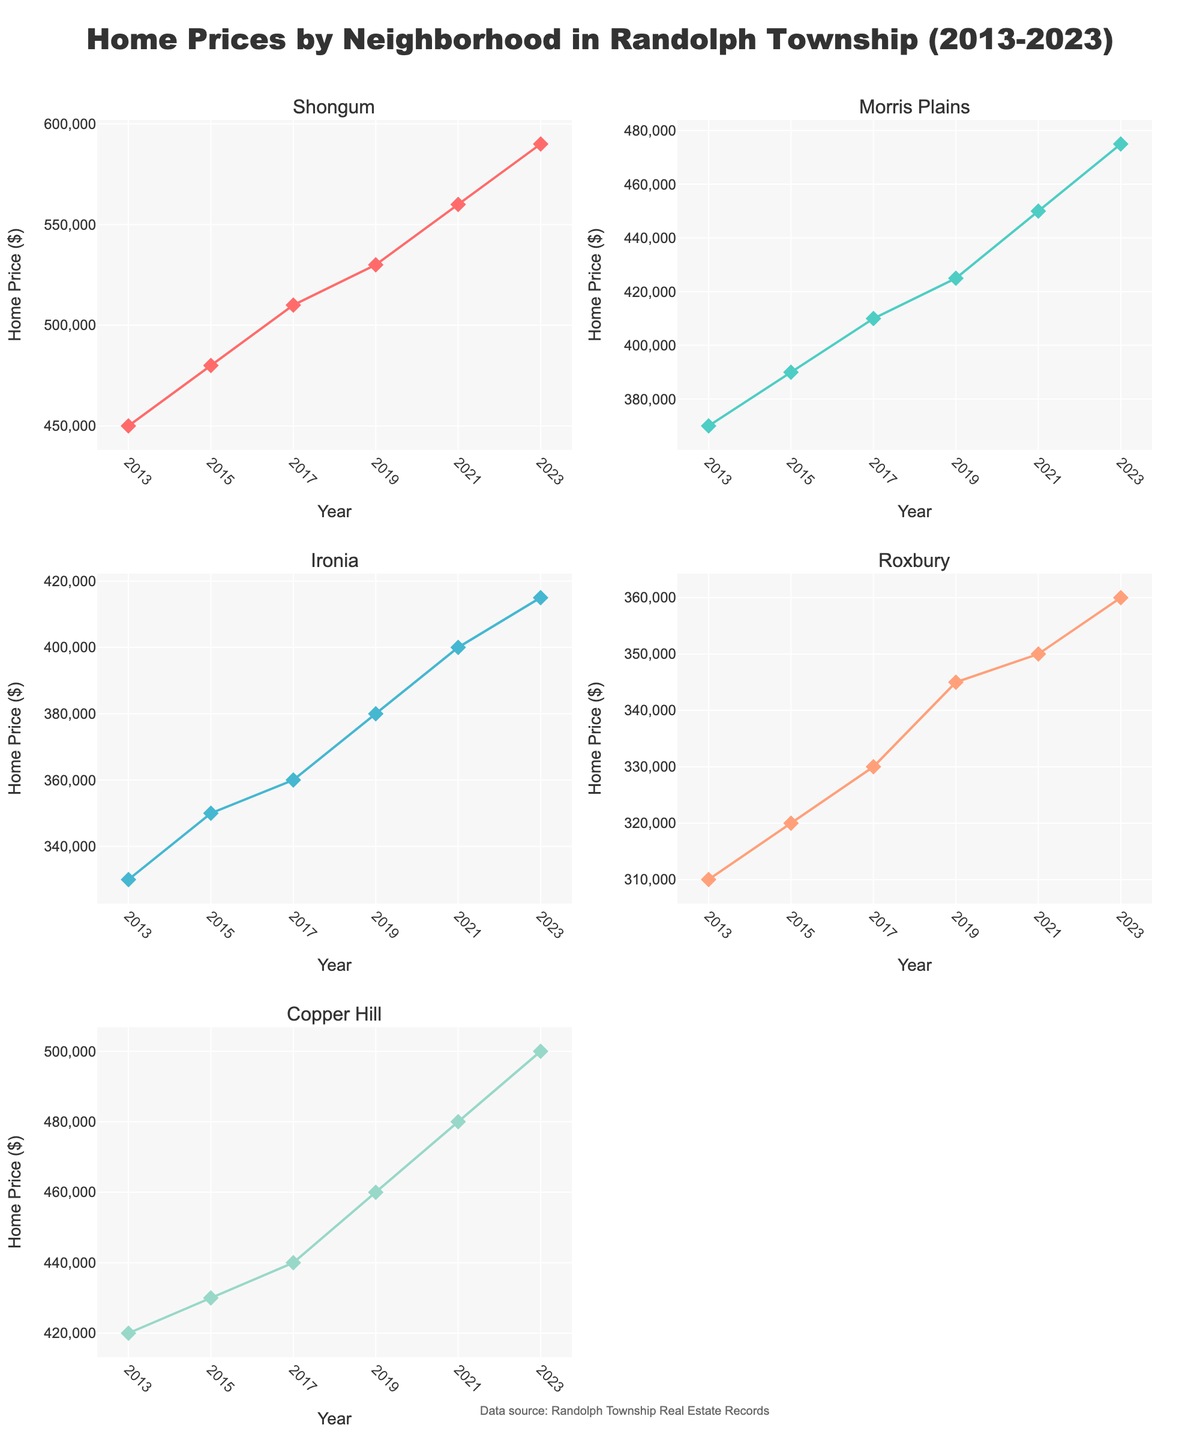what is the title of the figure? The title appears at the top of the figure and provides the main topic of the visualization. It helps to quickly understand the context of the data. The title should be the large and bold text at the top middle of the figure.
Answer: Home Prices by Neighborhood in Randolph Township (2013-2023) which neighborhood had the highest home price in 2023? By looking at the data points for the year 2023 across all subplots, we can identify the highest value. Specifically, we need to look for the highest y-point among the neighborhood plots.
Answer: Shongum how much did the home prices in Shongum increase from 2013 to 2015? Locate the Shongum subplot and look at the y-values for the years 2013 and 2015. Subtract the 2013 value from the 2015 value to find the increase.
Answer: $30,000 which neighborhood had the least change in home prices over the decade? Examine the range (difference between the highest and lowest home prices) for each neighborhood by looking at the y-axis spread across the subplot. The neighborhood with the smallest range is the one with the least change.
Answer: Roxbury in which year did Morris Plains experience the highest home price? Look at the Morris Plains subplot and find the data point with the highest y-value, then note the corresponding year on the x-axis.
Answer: 2023 what is the average home price in Copper Hill for the years shown? Add up the home prices for Copper Hill from all the years and divide by the number of years to calculate the average.
Answer: $455,000 how many neighborhoods have home prices exceeding $400,000 in 2023? Check the 2023 data points in each neighborhood's subplot and count how many of these points are above the $400,000 mark on the y-axis.
Answer: 4 compare the home price trends between Shongum and Ironia. Look at the line patterns in the Shongum and Ironia subplots. Observe whether they are increasing, decreasing, or stable and how steep the slopes are over the years.
Answer: Shongum consistently increased; Ironia showed a more gradual increase which neighborhood had a home price close to $300,000 in 2013? Look at the 2013 data points in each neighborhood's subplot and identify which one is nearest to the $300,000 mark on the y-axis.
Answer: Roxbury 